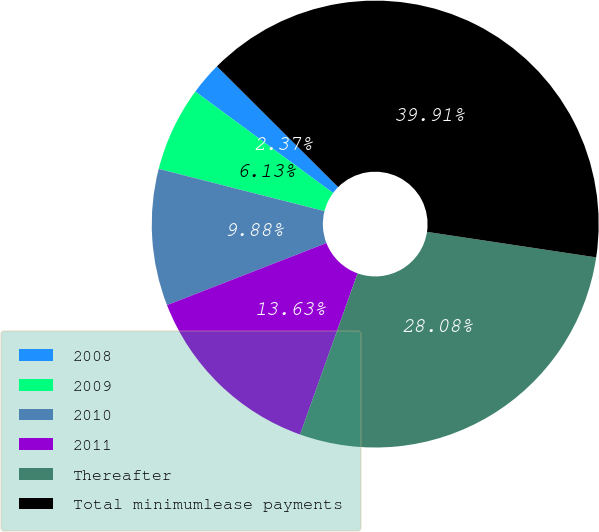<chart> <loc_0><loc_0><loc_500><loc_500><pie_chart><fcel>2008<fcel>2009<fcel>2010<fcel>2011<fcel>Thereafter<fcel>Total minimumlease payments<nl><fcel>2.37%<fcel>6.13%<fcel>9.88%<fcel>13.63%<fcel>28.08%<fcel>39.91%<nl></chart> 